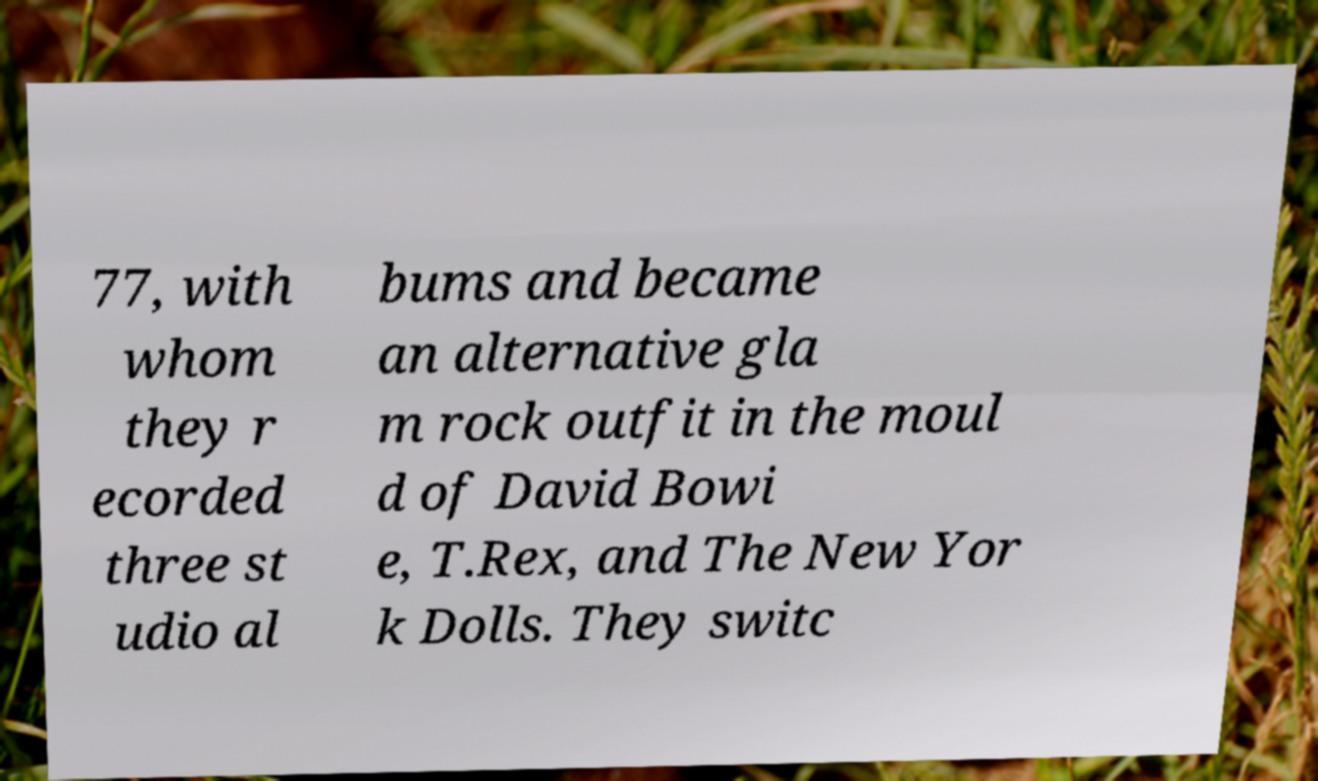Could you extract and type out the text from this image? 77, with whom they r ecorded three st udio al bums and became an alternative gla m rock outfit in the moul d of David Bowi e, T.Rex, and The New Yor k Dolls. They switc 